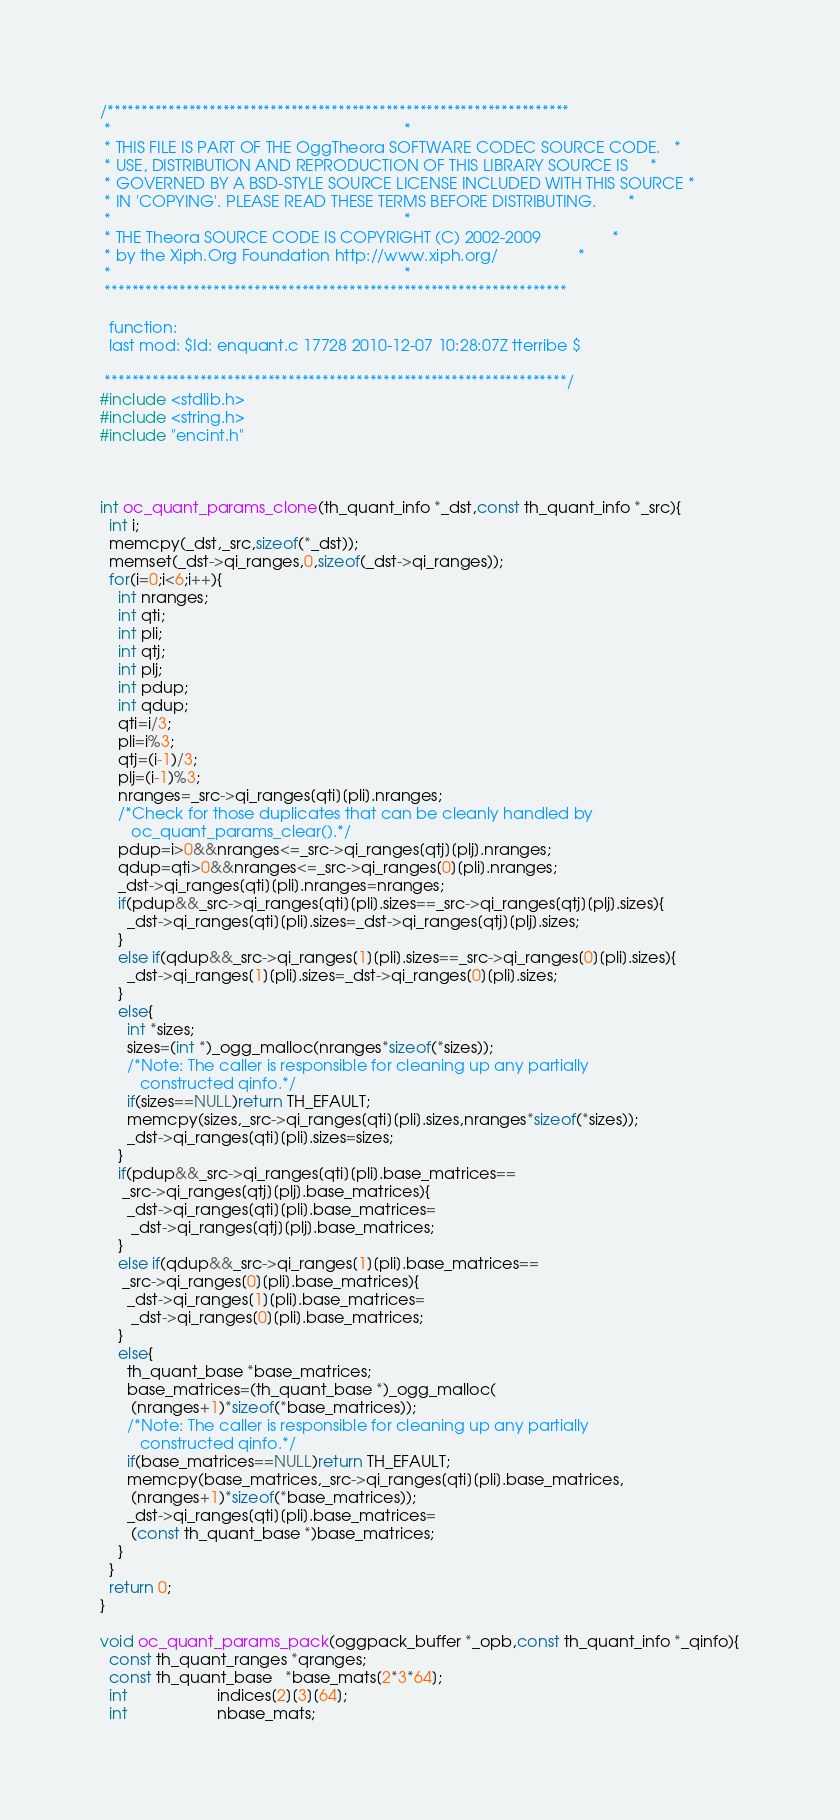<code> <loc_0><loc_0><loc_500><loc_500><_C_>/********************************************************************
 *                                                                  *
 * THIS FILE IS PART OF THE OggTheora SOFTWARE CODEC SOURCE CODE.   *
 * USE, DISTRIBUTION AND REPRODUCTION OF THIS LIBRARY SOURCE IS     *
 * GOVERNED BY A BSD-STYLE SOURCE LICENSE INCLUDED WITH THIS SOURCE *
 * IN 'COPYING'. PLEASE READ THESE TERMS BEFORE DISTRIBUTING.       *
 *                                                                  *
 * THE Theora SOURCE CODE IS COPYRIGHT (C) 2002-2009                *
 * by the Xiph.Org Foundation http://www.xiph.org/                  *
 *                                                                  *
 ********************************************************************

  function:
  last mod: $Id: enquant.c 17728 2010-12-07 10:28:07Z tterribe $

 ********************************************************************/
#include <stdlib.h>
#include <string.h>
#include "encint.h"



int oc_quant_params_clone(th_quant_info *_dst,const th_quant_info *_src){
  int i;
  memcpy(_dst,_src,sizeof(*_dst));
  memset(_dst->qi_ranges,0,sizeof(_dst->qi_ranges));
  for(i=0;i<6;i++){
    int nranges;
    int qti;
    int pli;
    int qtj;
    int plj;
    int pdup;
    int qdup;
    qti=i/3;
    pli=i%3;
    qtj=(i-1)/3;
    plj=(i-1)%3;
    nranges=_src->qi_ranges[qti][pli].nranges;
    /*Check for those duplicates that can be cleanly handled by
       oc_quant_params_clear().*/
    pdup=i>0&&nranges<=_src->qi_ranges[qtj][plj].nranges;
    qdup=qti>0&&nranges<=_src->qi_ranges[0][pli].nranges;
    _dst->qi_ranges[qti][pli].nranges=nranges;
    if(pdup&&_src->qi_ranges[qti][pli].sizes==_src->qi_ranges[qtj][plj].sizes){
      _dst->qi_ranges[qti][pli].sizes=_dst->qi_ranges[qtj][plj].sizes;
    }
    else if(qdup&&_src->qi_ranges[1][pli].sizes==_src->qi_ranges[0][pli].sizes){
      _dst->qi_ranges[1][pli].sizes=_dst->qi_ranges[0][pli].sizes;
    }
    else{
      int *sizes;
      sizes=(int *)_ogg_malloc(nranges*sizeof(*sizes));
      /*Note: The caller is responsible for cleaning up any partially
         constructed qinfo.*/
      if(sizes==NULL)return TH_EFAULT;
      memcpy(sizes,_src->qi_ranges[qti][pli].sizes,nranges*sizeof(*sizes));
      _dst->qi_ranges[qti][pli].sizes=sizes;
    }
    if(pdup&&_src->qi_ranges[qti][pli].base_matrices==
     _src->qi_ranges[qtj][plj].base_matrices){
      _dst->qi_ranges[qti][pli].base_matrices=
       _dst->qi_ranges[qtj][plj].base_matrices;
    }
    else if(qdup&&_src->qi_ranges[1][pli].base_matrices==
     _src->qi_ranges[0][pli].base_matrices){
      _dst->qi_ranges[1][pli].base_matrices=
       _dst->qi_ranges[0][pli].base_matrices;
    }
    else{
      th_quant_base *base_matrices;
      base_matrices=(th_quant_base *)_ogg_malloc(
       (nranges+1)*sizeof(*base_matrices));
      /*Note: The caller is responsible for cleaning up any partially
         constructed qinfo.*/
      if(base_matrices==NULL)return TH_EFAULT;
      memcpy(base_matrices,_src->qi_ranges[qti][pli].base_matrices,
       (nranges+1)*sizeof(*base_matrices));
      _dst->qi_ranges[qti][pli].base_matrices=
       (const th_quant_base *)base_matrices;
    }
  }
  return 0;
}

void oc_quant_params_pack(oggpack_buffer *_opb,const th_quant_info *_qinfo){
  const th_quant_ranges *qranges;
  const th_quant_base   *base_mats[2*3*64];
  int                    indices[2][3][64];
  int                    nbase_mats;</code> 